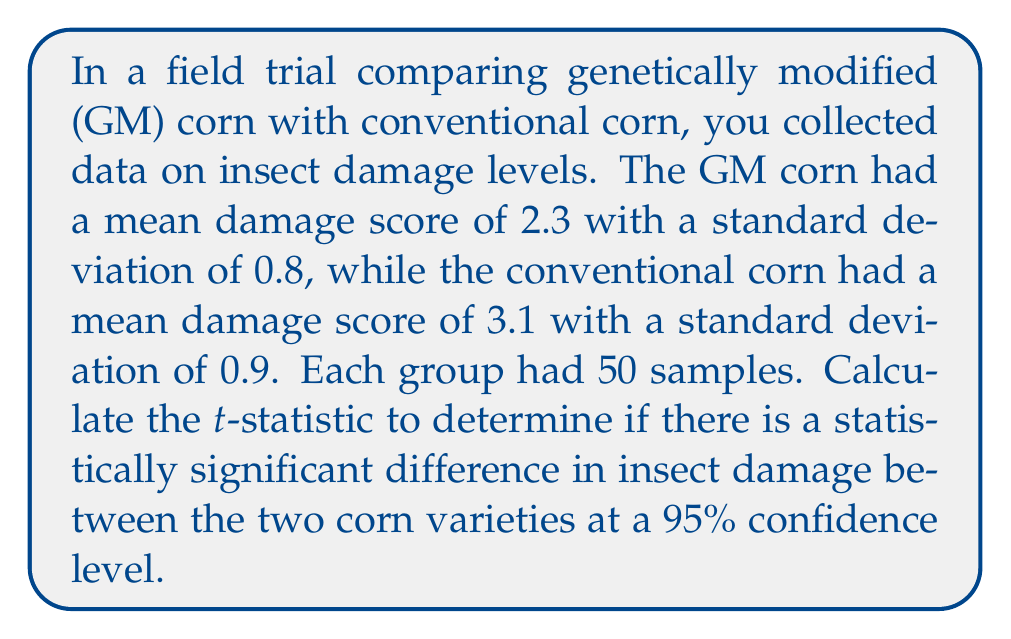Show me your answer to this math problem. To determine if there is a statistically significant difference between the two corn varieties, we need to calculate the t-statistic and compare it to the critical value for a 95% confidence level.

Step 1: Calculate the pooled standard deviation.
The formula for pooled standard deviation is:
$$s_p = \sqrt{\frac{(n_1 - 1)s_1^2 + (n_2 - 1)s_2^2}{n_1 + n_2 - 2}}$$

Where:
$n_1 = n_2 = 50$ (sample size for each group)
$s_1 = 0.8$ (standard deviation for GM corn)
$s_2 = 0.9$ (standard deviation for conventional corn)

$$s_p = \sqrt{\frac{(50 - 1)(0.8)^2 + (50 - 1)(0.9)^2}{50 + 50 - 2}}$$
$$s_p = \sqrt{\frac{31.36 + 39.69}{98}} = \sqrt{0.7261} = 0.8522$$

Step 2: Calculate the t-statistic.
The formula for the t-statistic is:
$$t = \frac{\bar{x_1} - \bar{x_2}}{s_p \sqrt{\frac{2}{n}}}$$

Where:
$\bar{x_1} = 2.3$ (mean for GM corn)
$\bar{x_2} = 3.1$ (mean for conventional corn)
$n = 50$ (sample size for each group)

$$t = \frac{2.3 - 3.1}{0.8522 \sqrt{\frac{2}{50}}}$$
$$t = \frac{-0.8}{0.8522 \sqrt{0.04}} = \frac{-0.8}{0.1704} = -4.6948$$

Step 3: Determine the critical value.
For a 95% confidence level with 98 degrees of freedom (n1 + n2 - 2), the critical value is approximately ±1.984 (from a t-table).

Step 4: Compare the t-statistic to the critical value.
The absolute value of our t-statistic (4.6948) is greater than the critical value (1.984), indicating a statistically significant difference between the two corn varieties at the 95% confidence level.
Answer: $t = -4.6948$ 